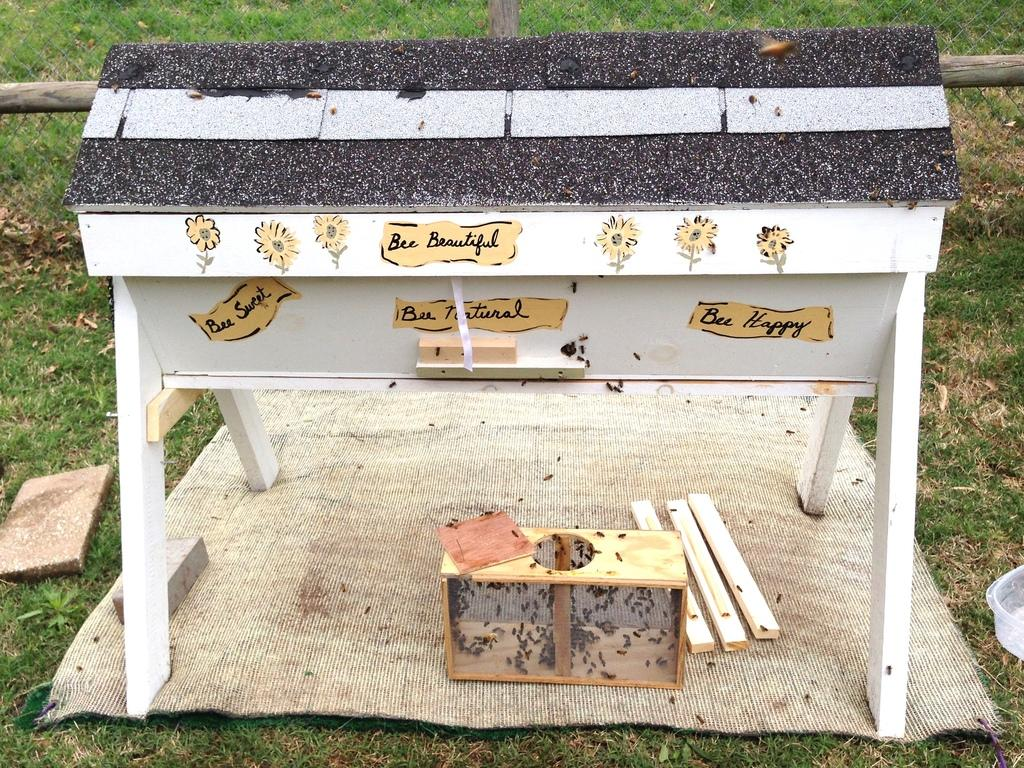<image>
Summarize the visual content of the image. An artificial beehive has phrases like "Bee Beautiful" and "Bee Happy" on it. 